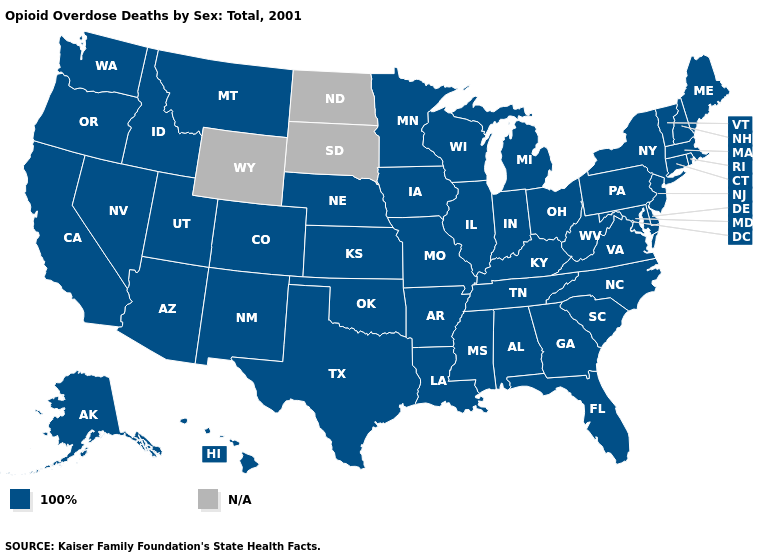Name the states that have a value in the range N/A?
Quick response, please. North Dakota, South Dakota, Wyoming. What is the highest value in the Northeast ?
Write a very short answer. 100%. What is the lowest value in states that border Washington?
Write a very short answer. 100%. Among the states that border Nebraska , which have the highest value?
Answer briefly. Colorado, Iowa, Kansas, Missouri. Name the states that have a value in the range N/A?
Give a very brief answer. North Dakota, South Dakota, Wyoming. Does the map have missing data?
Write a very short answer. Yes. How many symbols are there in the legend?
Write a very short answer. 2. Among the states that border New Mexico , which have the lowest value?
Give a very brief answer. Arizona, Colorado, Oklahoma, Texas, Utah. Which states have the lowest value in the USA?
Answer briefly. Alabama, Alaska, Arizona, Arkansas, California, Colorado, Connecticut, Delaware, Florida, Georgia, Hawaii, Idaho, Illinois, Indiana, Iowa, Kansas, Kentucky, Louisiana, Maine, Maryland, Massachusetts, Michigan, Minnesota, Mississippi, Missouri, Montana, Nebraska, Nevada, New Hampshire, New Jersey, New Mexico, New York, North Carolina, Ohio, Oklahoma, Oregon, Pennsylvania, Rhode Island, South Carolina, Tennessee, Texas, Utah, Vermont, Virginia, Washington, West Virginia, Wisconsin. Which states have the lowest value in the USA?
Quick response, please. Alabama, Alaska, Arizona, Arkansas, California, Colorado, Connecticut, Delaware, Florida, Georgia, Hawaii, Idaho, Illinois, Indiana, Iowa, Kansas, Kentucky, Louisiana, Maine, Maryland, Massachusetts, Michigan, Minnesota, Mississippi, Missouri, Montana, Nebraska, Nevada, New Hampshire, New Jersey, New Mexico, New York, North Carolina, Ohio, Oklahoma, Oregon, Pennsylvania, Rhode Island, South Carolina, Tennessee, Texas, Utah, Vermont, Virginia, Washington, West Virginia, Wisconsin. Is the legend a continuous bar?
Answer briefly. No. Does the map have missing data?
Keep it brief. Yes. Which states hav the highest value in the South?
Keep it brief. Alabama, Arkansas, Delaware, Florida, Georgia, Kentucky, Louisiana, Maryland, Mississippi, North Carolina, Oklahoma, South Carolina, Tennessee, Texas, Virginia, West Virginia. Among the states that border Nevada , which have the lowest value?
Write a very short answer. Arizona, California, Idaho, Oregon, Utah. 